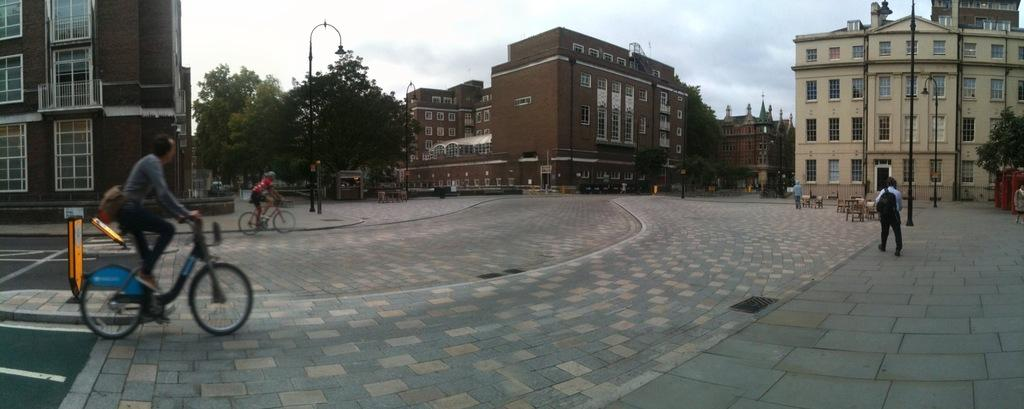How many people are in the image? There are two people in the image. What are the two people doing in the image? The two people are riding bicycles. What can be seen in the background of the image? The background of the image is the sky. What type of crown is the person wearing on their skin in the image? There is no crown or reference to skin in the image; the two people are riding bicycles with the sky as the background. 